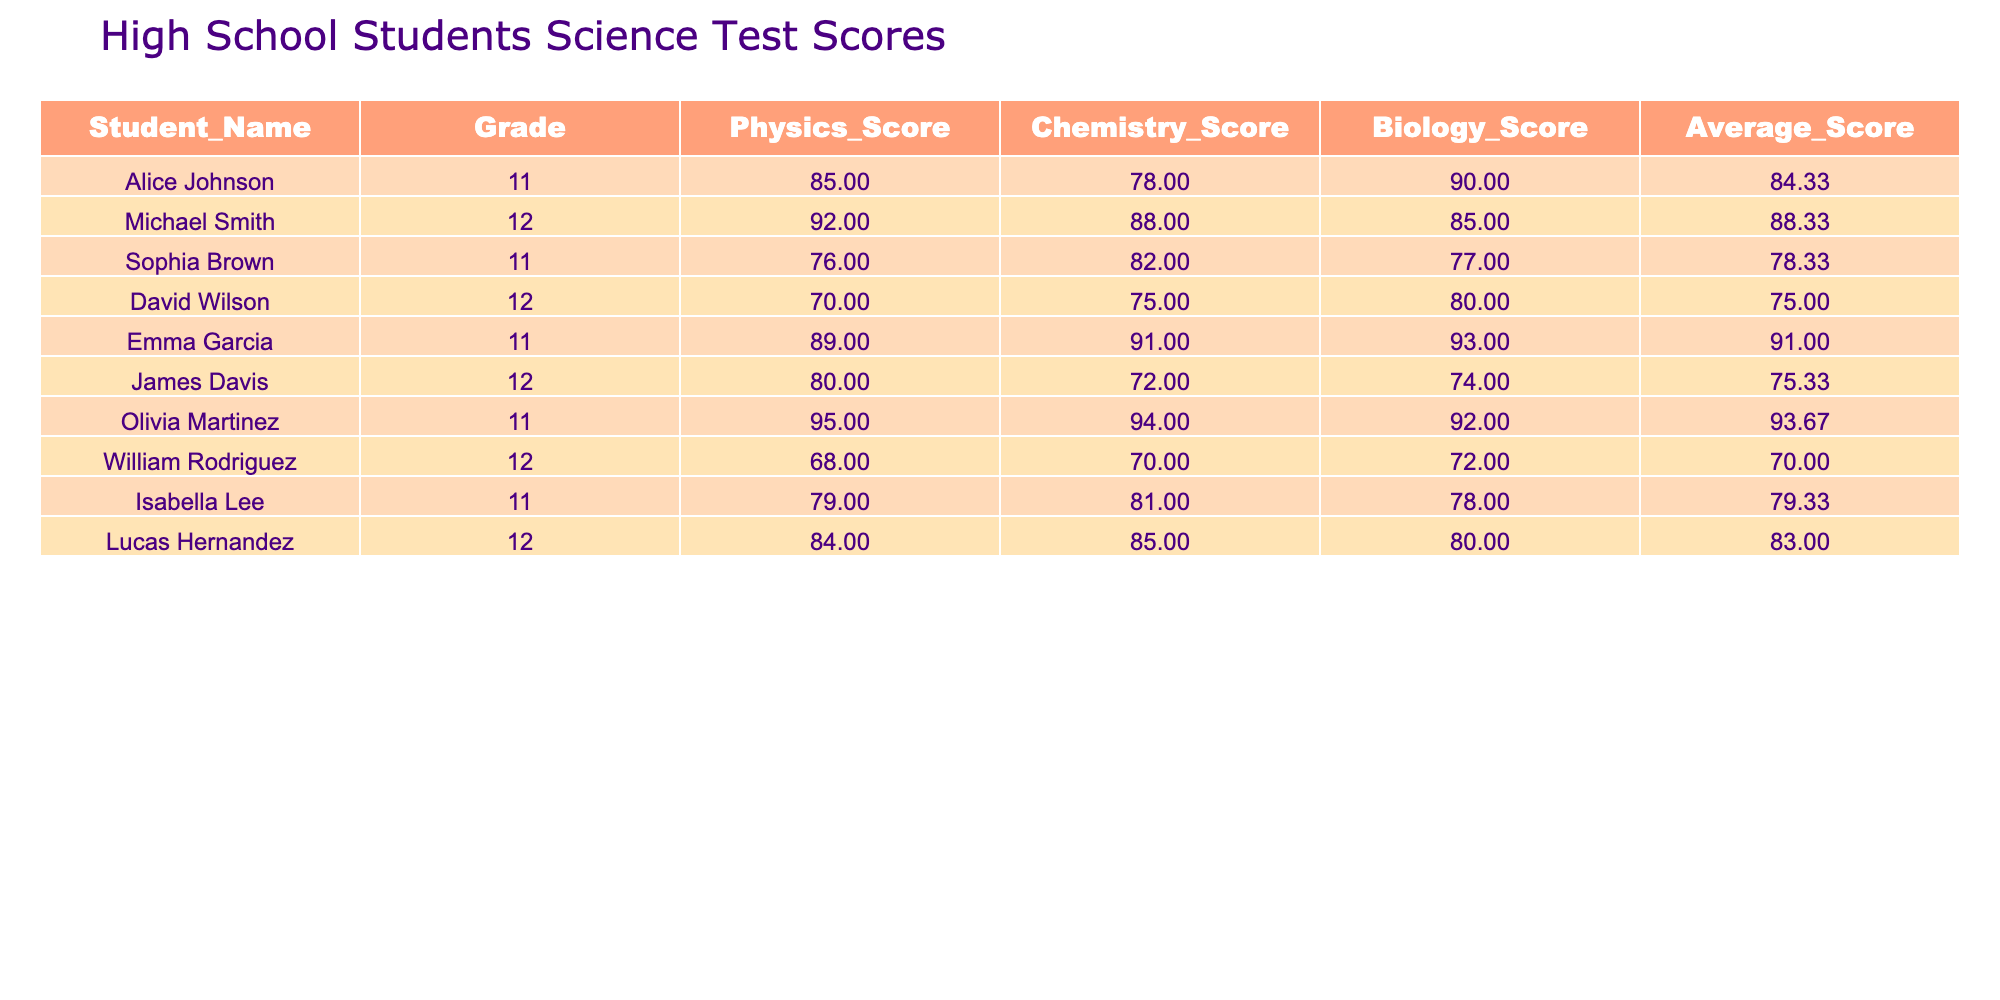What is the average score for Emma Garcia? To find Emma Garcia's average score, we can directly refer to the table where her name is listed. Her average score is provided as 91.00.
Answer: 91.00 Which student scored the highest in Physics? By scanning the Physics Score column, Olivia Martinez has the highest score of 95, which is the maximum compared to other students.
Answer: 95 What is the median Biology score? To find the median, we first list the Biology scores: 90, 85, 77, 80, 93, 74, 92, 72, 78, and 93. Sorting these gives us: 72, 74, 77, 78, 80, 82, 85, 90, 92, 93. The median is the average of the 5th and 6th scores, which are 80 and 82. Therefore, (80 + 82) / 2 = 81.
Answer: 81 Did any student have a perfect score in any subject? Reviewing the scores across all subjects, none of the students have a score of 100 or higher in Physics, Chemistry, or Biology. Thus, no student achieved a perfect score in any subject.
Answer: No Which subject had the highest average score among all students? We calculate the average for each subject: Physics: (85 + 92 + 76 + 70 + 89 + 80 + 95 + 68 + 79 + 84) / 10 = 80.8, Chemistry: (78 + 88 + 82 + 75 + 91 + 72 + 94 + 70 + 81 + 85) / 10 = 80.6, and Biology: (90 + 85 + 77 + 80 + 93 + 74 + 92 + 72 + 78 + 80) / 10 = 80.9. Since Biology has the highest average score of 80.9, it is the subject with the best average.
Answer: Biology What is the average score of students in Grade 11? For Grade 11, we take Alice Johnson (84.33), Sophia Brown (78.33), Emma Garcia (91.00), Olivia Martinez (93.67), and Isabella Lee (79.33). Their total average score is (84.33 + 78.33 + 91.00 + 93.67 + 79.33) / 5 = 85.33.
Answer: 85.33 Is there a student whose average score is below 75? Looking at the Average Score column, David Wilson (75.00) and William Rodriguez (70.00) have scores. Since 70 is below 75, we conclude there is indeed a student with an average score below 75.
Answer: Yes Which student had the second lowest score in Chemistry? From the Chemistry scores, we find David Wilson (75) had the lowest, followed by James Davis (72). Thus James Davis had the second lowest score in Chemistry.
Answer: 72 